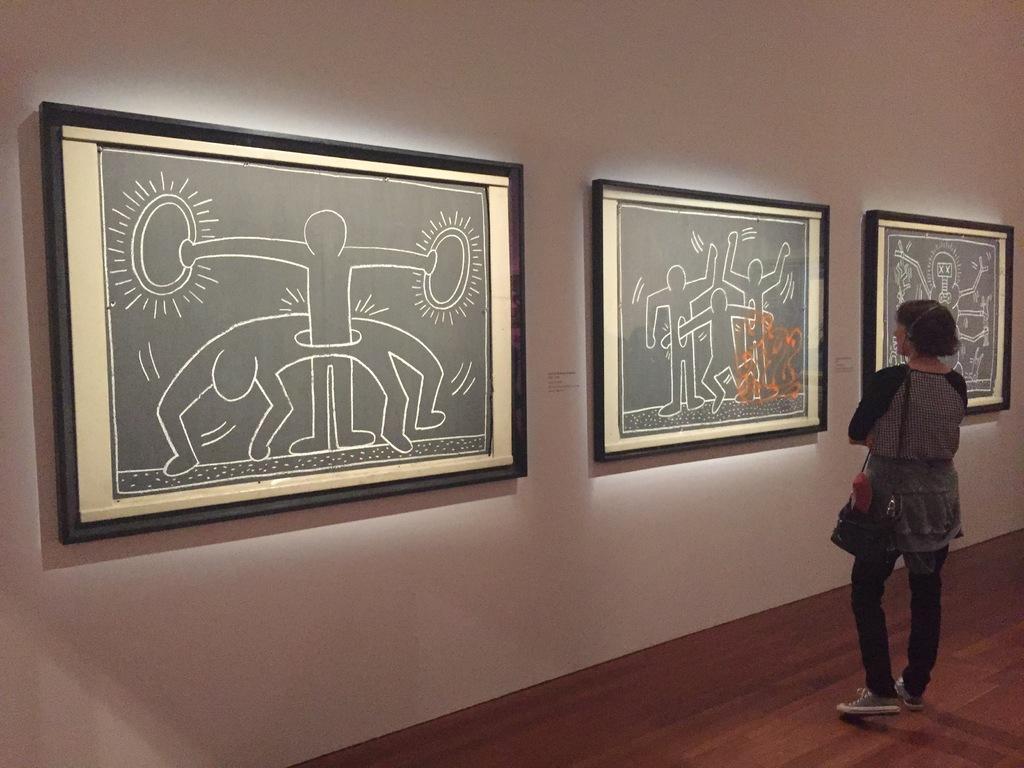How would you summarize this image in a sentence or two? In this picture there is a woman standing in the right corner and there are few photo frames attached to the wall in front of her. 